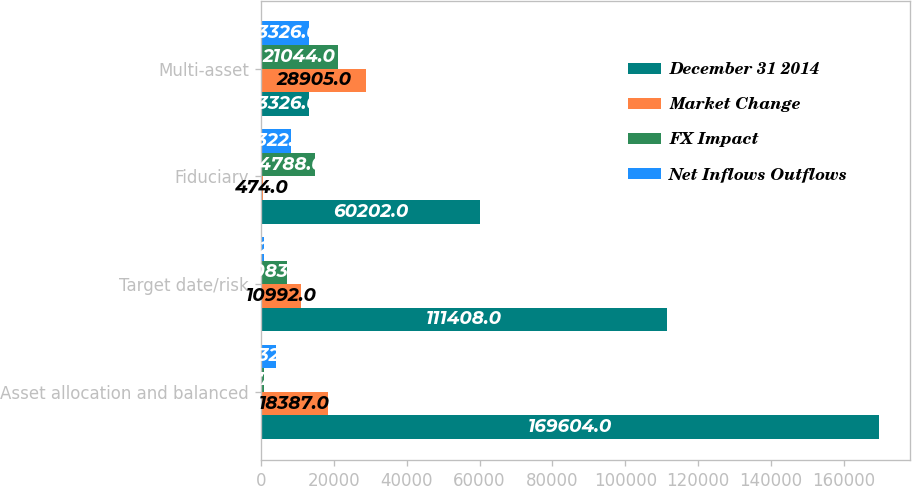<chart> <loc_0><loc_0><loc_500><loc_500><stacked_bar_chart><ecel><fcel>Asset allocation and balanced<fcel>Target date/risk<fcel>Fiduciary<fcel>Multi-asset<nl><fcel>December 31 2014<fcel>169604<fcel>111408<fcel>60202<fcel>13326<nl><fcel>Market Change<fcel>18387<fcel>10992<fcel>474<fcel>28905<nl><fcel>FX Impact<fcel>827<fcel>7083<fcel>14788<fcel>21044<nl><fcel>Net Inflows Outflows<fcel>4132<fcel>872<fcel>8322<fcel>13326<nl></chart> 